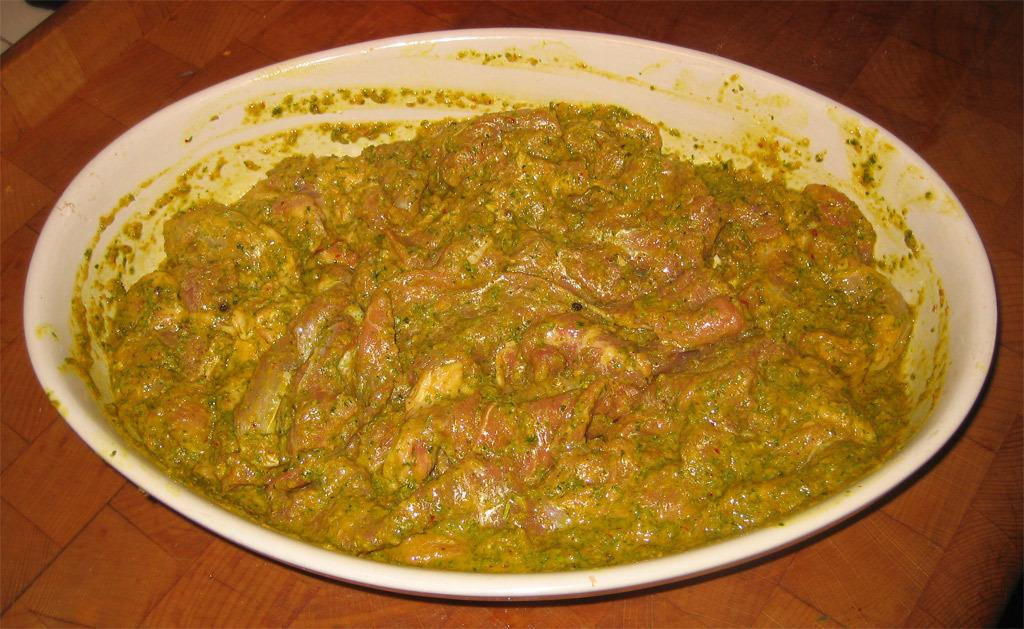What type of food item is in the image? The specific type of food item is not mentioned, but it is a food item. What color is the bowl that contains the food item? The bowl is white. Where is the bowl with the food item located? The bowl is placed on a table. What flavor of ice cream is being added to the bowl in the image? There is no mention of ice cream or any specific flavor in the image. 